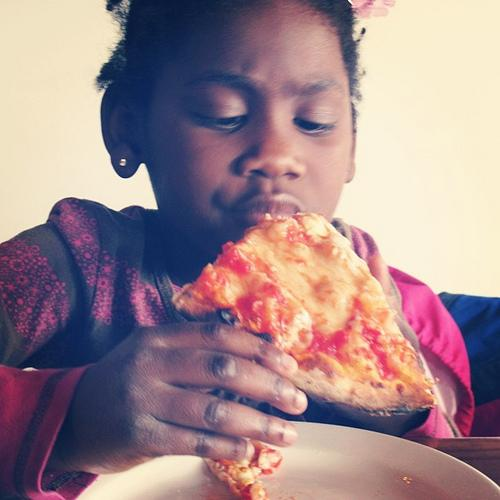Count the total number of pizza slices present in the image. There are three pizza slices - a large one, a smaller one, and a small piece. Analyze the sentiment of the image based on its objects and their interactions. The image conveys a happy, casual atmosphere as a young girl enjoys eating a large slice of cheese pizza while wearing a colorful, comfortable hoodie. What is the primary object in the image that appears to be interacting with a person? A slice of cheese pizza is being held and eaten by a young black child wearing a pink sweater. What is the girl's earring made of, and what is its shape? The girl's earring is a small, diamond-shaped earring made of a shiny material, likely metal or gemstone. List down the facial features of the girl that are visible in the image. The girl has a curly hair, left and right eyebrows, left and right eyes, a nose, lips, and a diamond earring. Provide a brief description of the objects that are not directly related to the main subject. Apart from the main subject, there are objects like a light pink flower, a nearly clean plate, and a large white wall with a yellow portion. Describe the color of the wall and what type of plate is shown in the image. The wall is white with a yellow portion, and the plate is a nearly clean, round, white ceramic plate. Identify the type of pizza and its characteristic in the image. It's a large slice of cheese and tomato pizza with bubbled cheese and slightly burnt crust. What type of clothing is the girl wearing and what is the design on it? The girl is wearing a mostly pink hoodie with a red and brown floral top and a dark sewing stripe on the hoodie. 